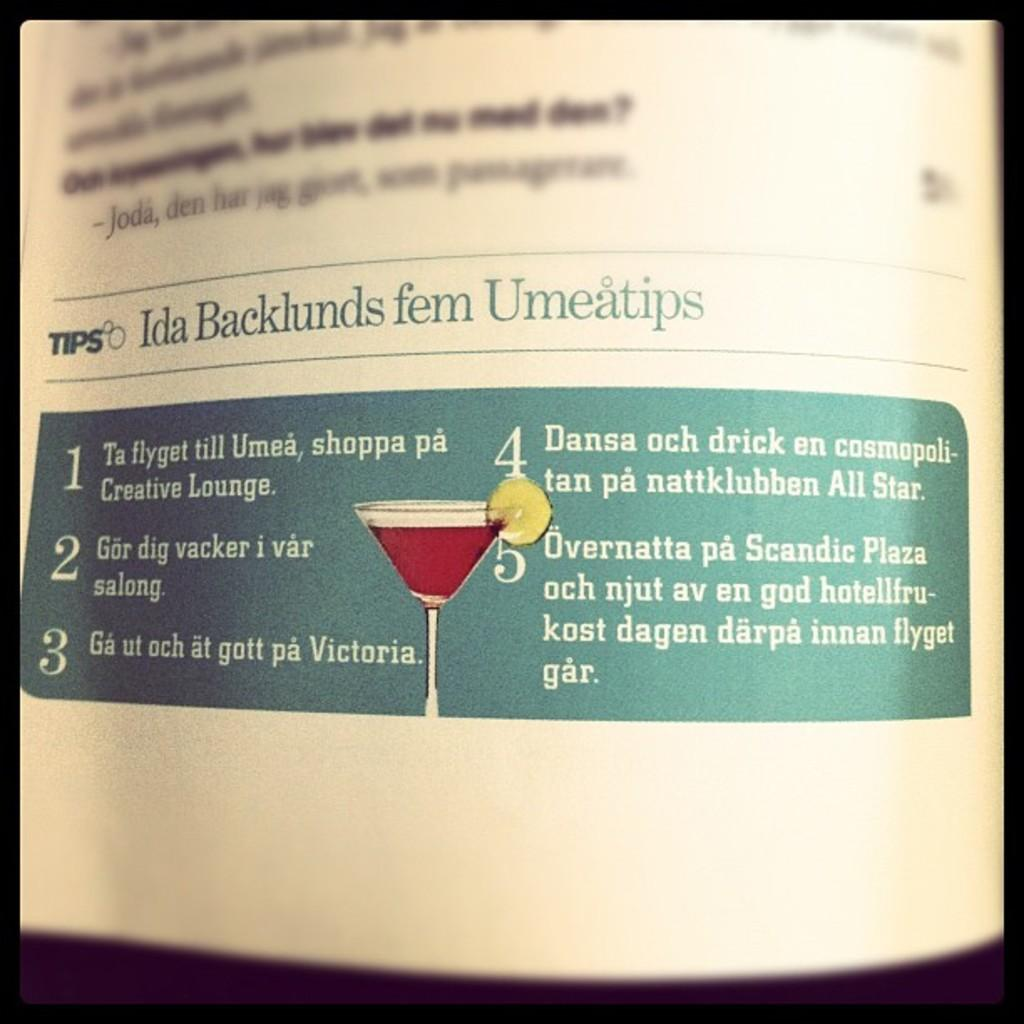<image>
Present a compact description of the photo's key features. A book details how to make a cocktail 